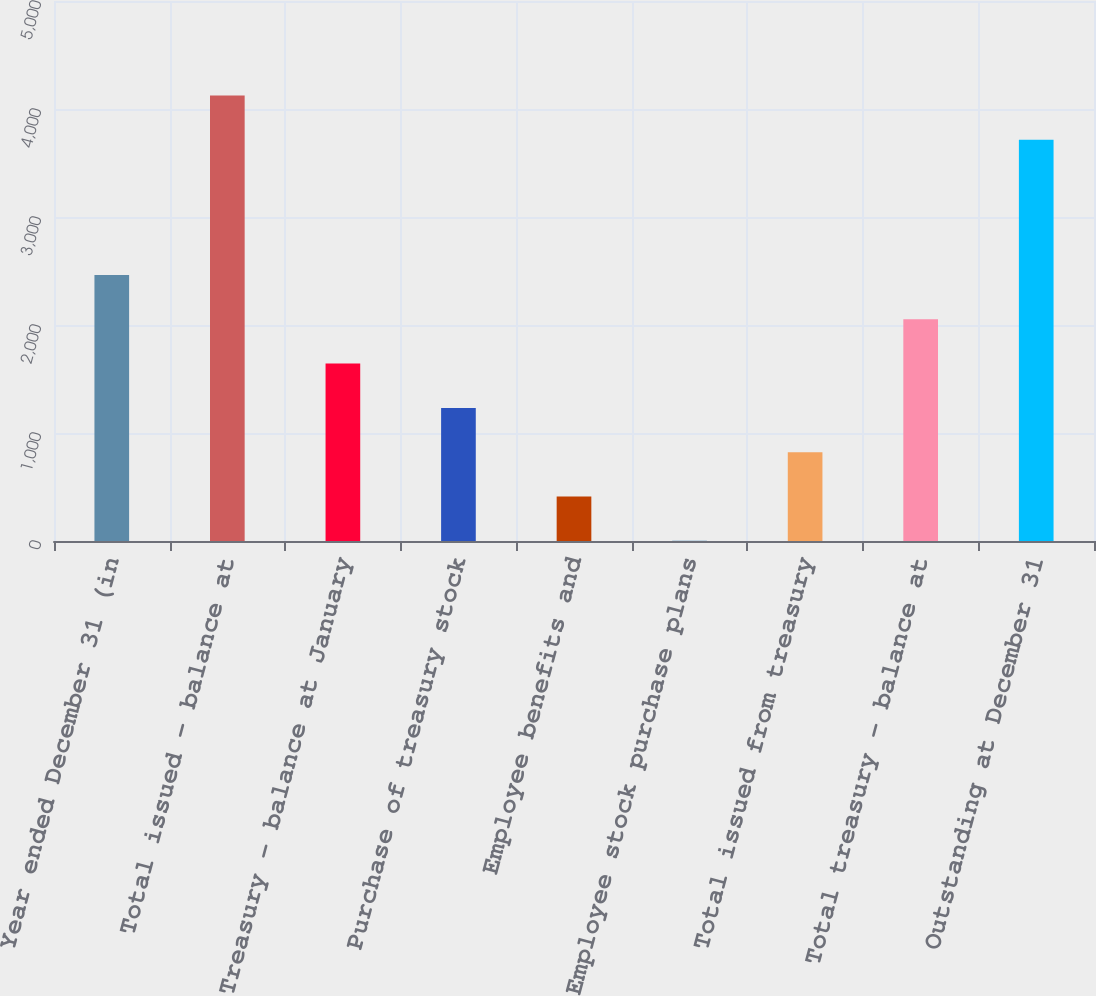Convert chart. <chart><loc_0><loc_0><loc_500><loc_500><bar_chart><fcel>Year ended December 31 (in<fcel>Total issued - balance at<fcel>Treasury - balance at January<fcel>Purchase of treasury stock<fcel>Employee benefits and<fcel>Employee stock purchase plans<fcel>Total issued from treasury<fcel>Total treasury - balance at<fcel>Outstanding at December 31<nl><fcel>2463.42<fcel>4125.17<fcel>1642.68<fcel>1232.31<fcel>411.57<fcel>1.2<fcel>821.94<fcel>2053.05<fcel>3714.8<nl></chart> 